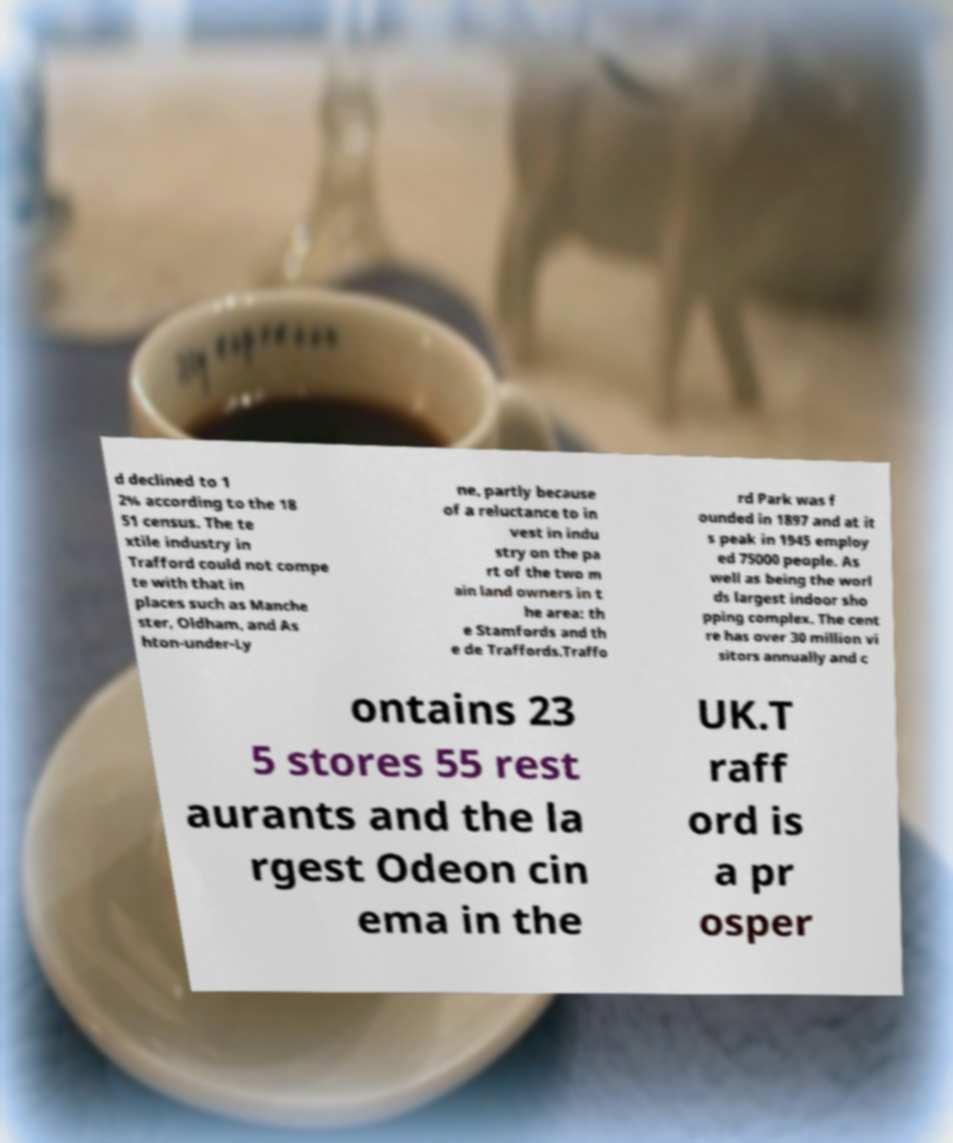I need the written content from this picture converted into text. Can you do that? d declined to 1 2% according to the 18 51 census. The te xtile industry in Trafford could not compe te with that in places such as Manche ster, Oldham, and As hton-under-Ly ne, partly because of a reluctance to in vest in indu stry on the pa rt of the two m ain land owners in t he area: th e Stamfords and th e de Traffords.Traffo rd Park was f ounded in 1897 and at it s peak in 1945 employ ed 75000 people. As well as being the worl ds largest indoor sho pping complex. The cent re has over 30 million vi sitors annually and c ontains 23 5 stores 55 rest aurants and the la rgest Odeon cin ema in the UK.T raff ord is a pr osper 